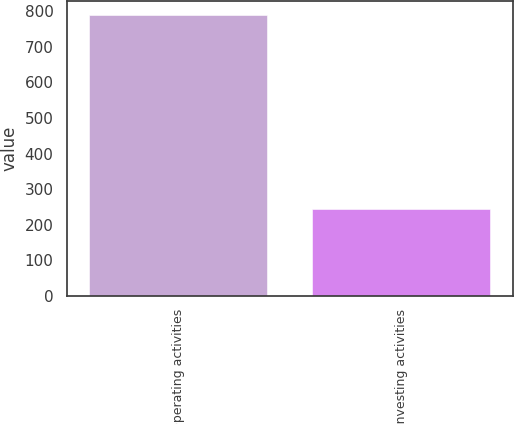<chart> <loc_0><loc_0><loc_500><loc_500><bar_chart><fcel>Operating activities<fcel>Investing activities<nl><fcel>789<fcel>244<nl></chart> 